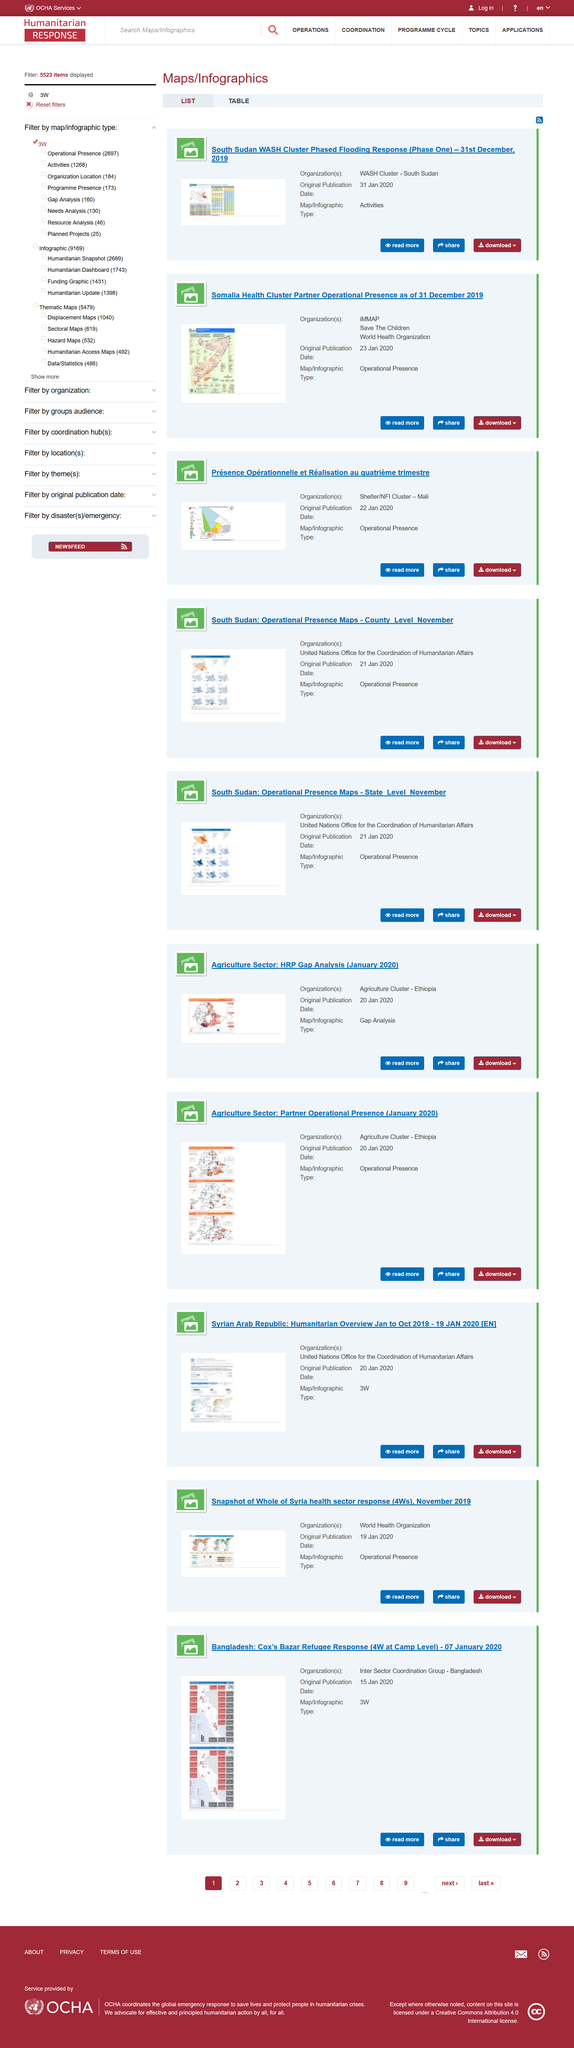Indicate a few pertinent items in this graphic. The flooding response map referred to in the document is for South Sudan. iMMAP, Save the Children, and the World Health Organization are present in Somalia. The original publication date of the South Sudan Flooding response was January 31, 2020. 